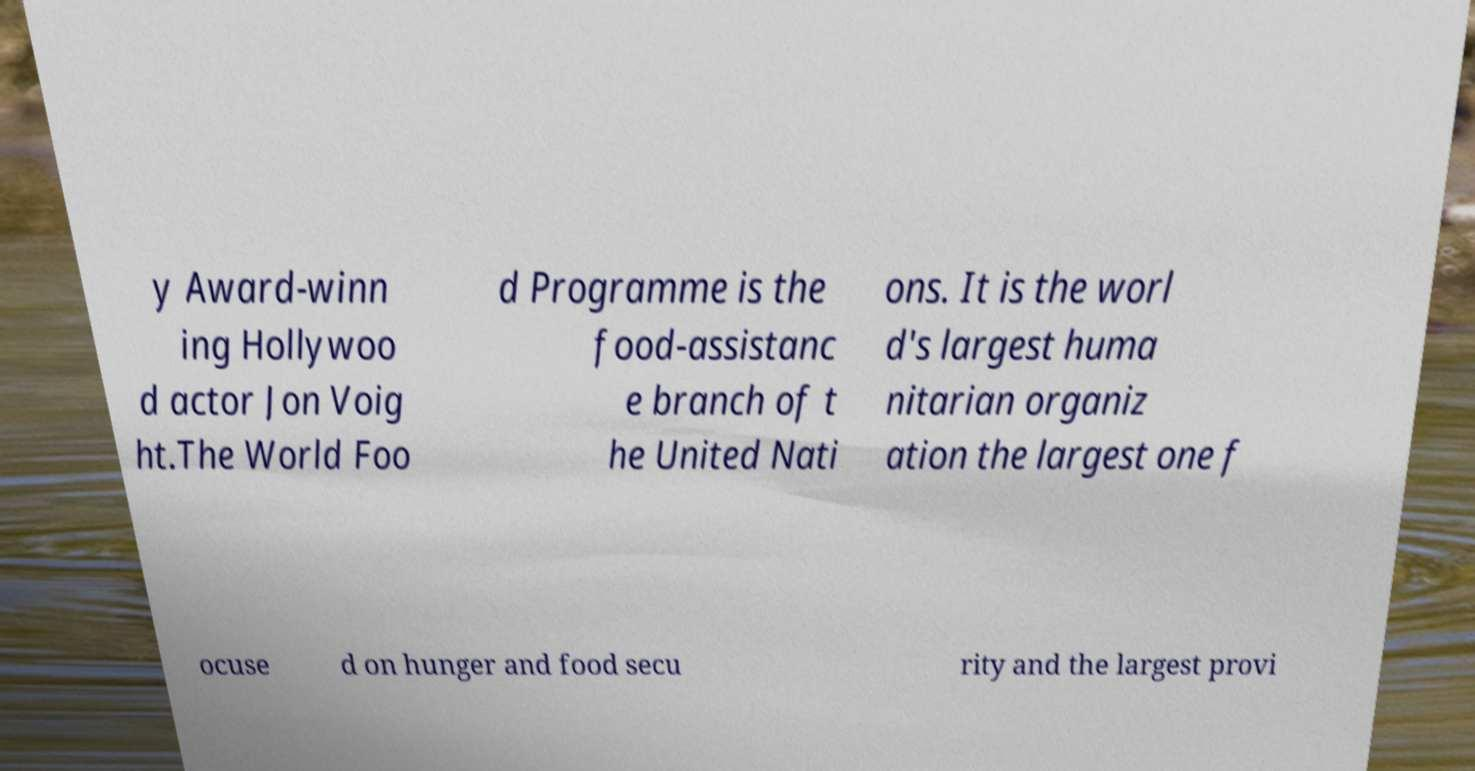There's text embedded in this image that I need extracted. Can you transcribe it verbatim? y Award-winn ing Hollywoo d actor Jon Voig ht.The World Foo d Programme is the food-assistanc e branch of t he United Nati ons. It is the worl d's largest huma nitarian organiz ation the largest one f ocuse d on hunger and food secu rity and the largest provi 